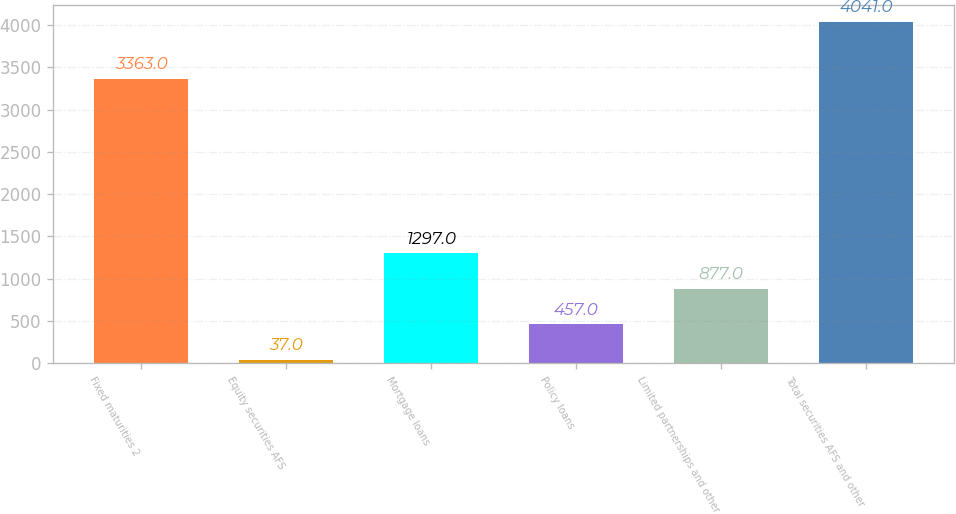Convert chart to OTSL. <chart><loc_0><loc_0><loc_500><loc_500><bar_chart><fcel>Fixed maturities 2<fcel>Equity securities AFS<fcel>Mortgage loans<fcel>Policy loans<fcel>Limited partnerships and other<fcel>Total securities AFS and other<nl><fcel>3363<fcel>37<fcel>1297<fcel>457<fcel>877<fcel>4041<nl></chart> 